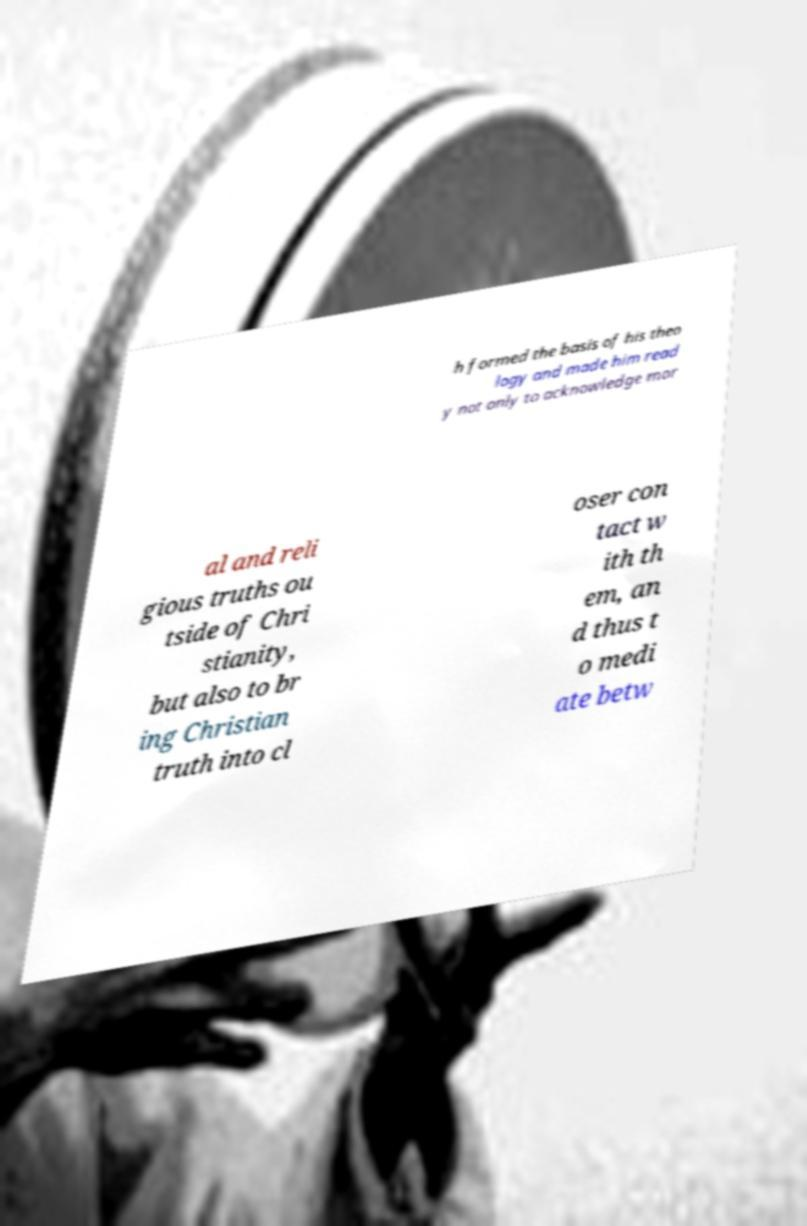What messages or text are displayed in this image? I need them in a readable, typed format. h formed the basis of his theo logy and made him read y not only to acknowledge mor al and reli gious truths ou tside of Chri stianity, but also to br ing Christian truth into cl oser con tact w ith th em, an d thus t o medi ate betw 